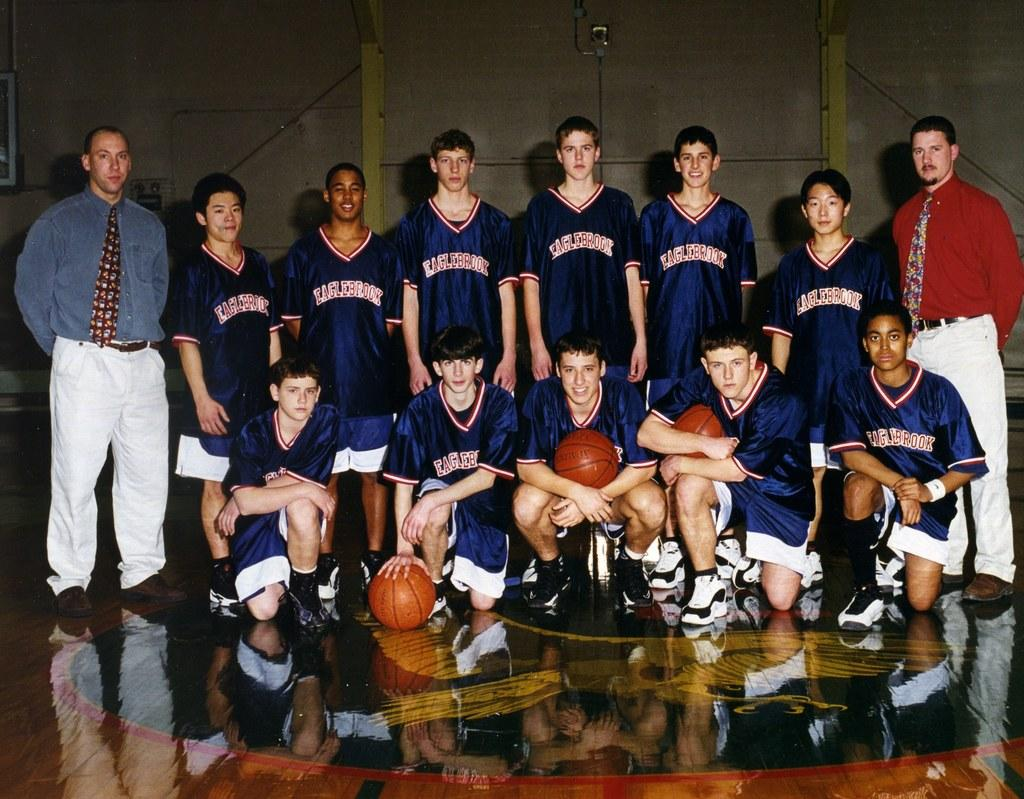<image>
Share a concise interpretation of the image provided. The basketball team from Eaglebrook poses for their photograph. 